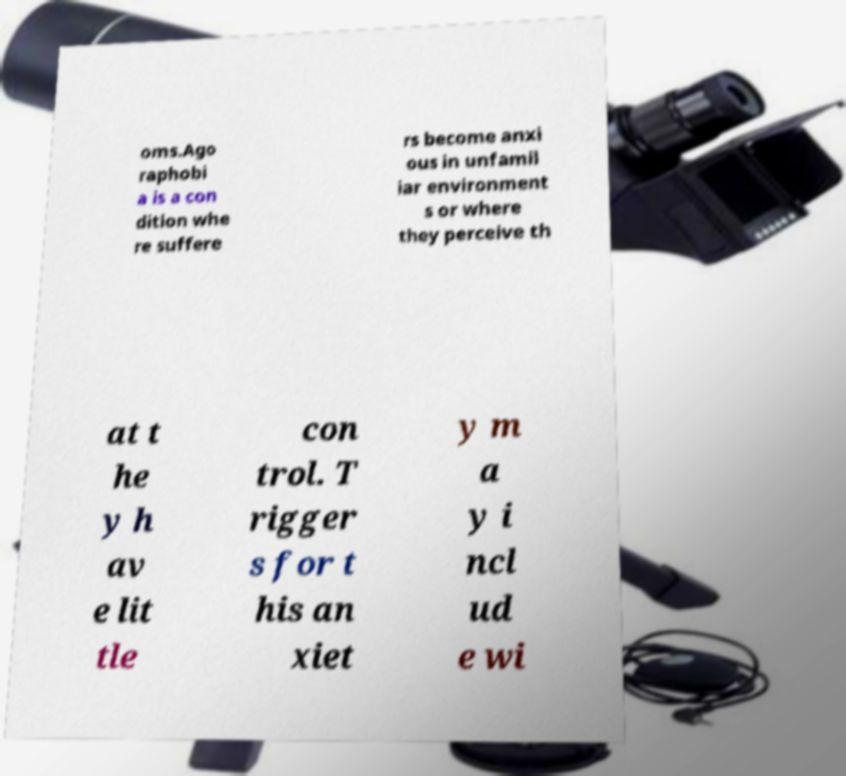Can you read and provide the text displayed in the image?This photo seems to have some interesting text. Can you extract and type it out for me? oms.Ago raphobi a is a con dition whe re suffere rs become anxi ous in unfamil iar environment s or where they perceive th at t he y h av e lit tle con trol. T rigger s for t his an xiet y m a y i ncl ud e wi 